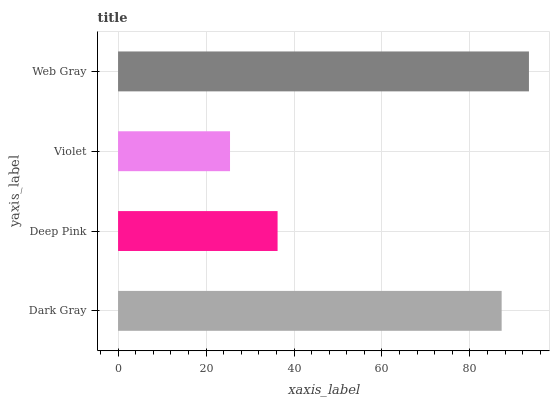Is Violet the minimum?
Answer yes or no. Yes. Is Web Gray the maximum?
Answer yes or no. Yes. Is Deep Pink the minimum?
Answer yes or no. No. Is Deep Pink the maximum?
Answer yes or no. No. Is Dark Gray greater than Deep Pink?
Answer yes or no. Yes. Is Deep Pink less than Dark Gray?
Answer yes or no. Yes. Is Deep Pink greater than Dark Gray?
Answer yes or no. No. Is Dark Gray less than Deep Pink?
Answer yes or no. No. Is Dark Gray the high median?
Answer yes or no. Yes. Is Deep Pink the low median?
Answer yes or no. Yes. Is Web Gray the high median?
Answer yes or no. No. Is Dark Gray the low median?
Answer yes or no. No. 